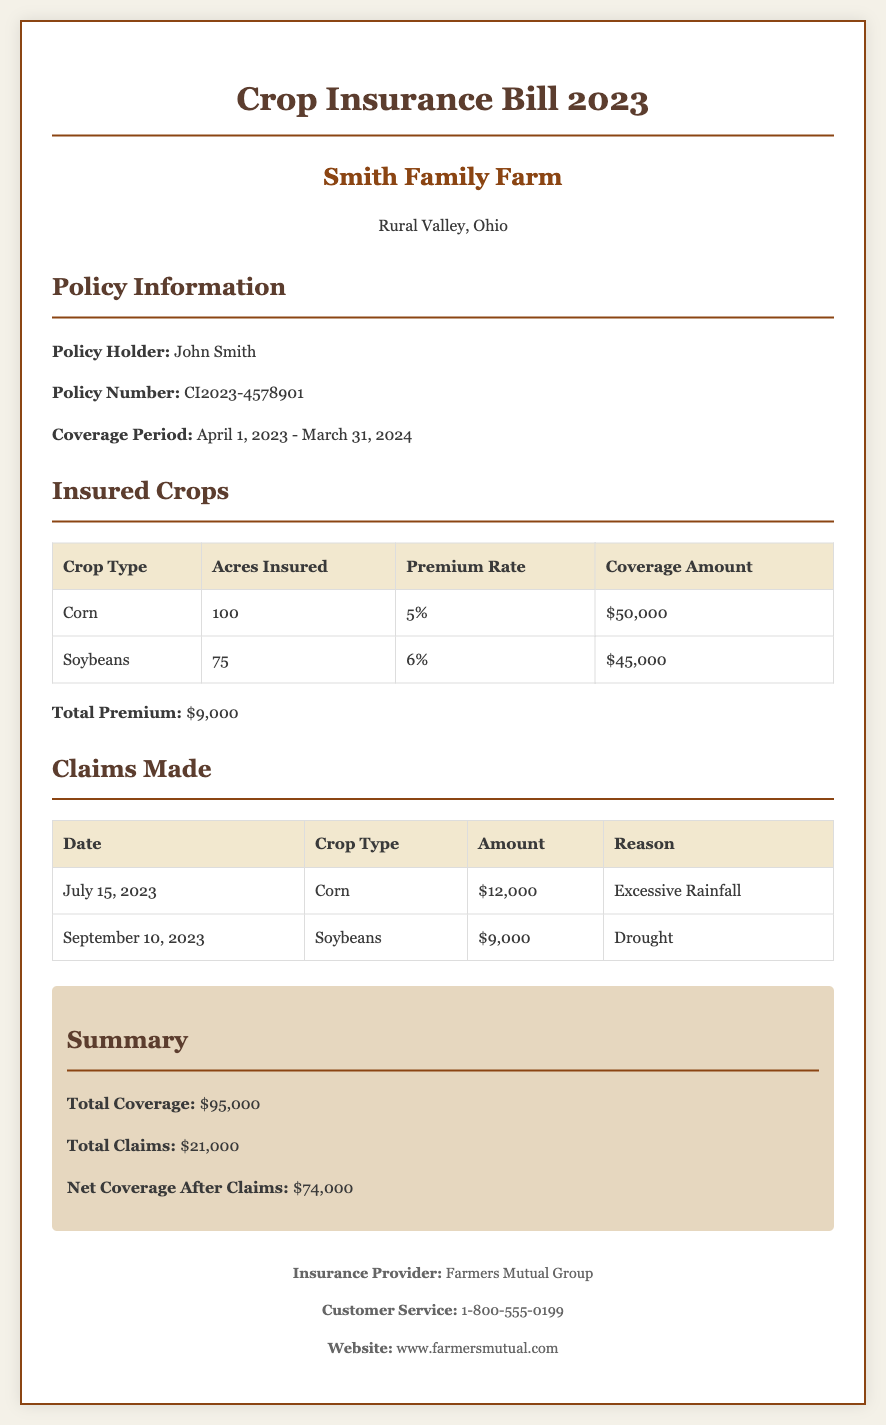What is the policy number? The policy number is specified in the document under Policy Information.
Answer: CI2023-4578901 What is the coverage period? The coverage period is stated directly in the Policy Information section.
Answer: April 1, 2023 - March 31, 2024 How much is the premium for Soybeans? The premium rate for Soybeans is listed in the Insured Crops table.
Answer: 6% What is the total amount claimed for Corn? The total amount claimed for Corn is found in the Claims Made table.
Answer: $12,000 What is the total coverage amount? The total coverage amount is summarized in the Summary section.
Answer: $95,000 How much was claimed due to drought? The amount claimed for drought is detailed in the Claims Made table.
Answer: $9,000 What is the total premium paid? The total premium is provided at the end of the Insured Crops section.
Answer: $9,000 What is the net coverage after claims? The net coverage after claims is included in the Summary.
Answer: $74,000 Who is the insurance provider? The insurance provider's name is listed in the footer of the document.
Answer: Farmers Mutual Group 